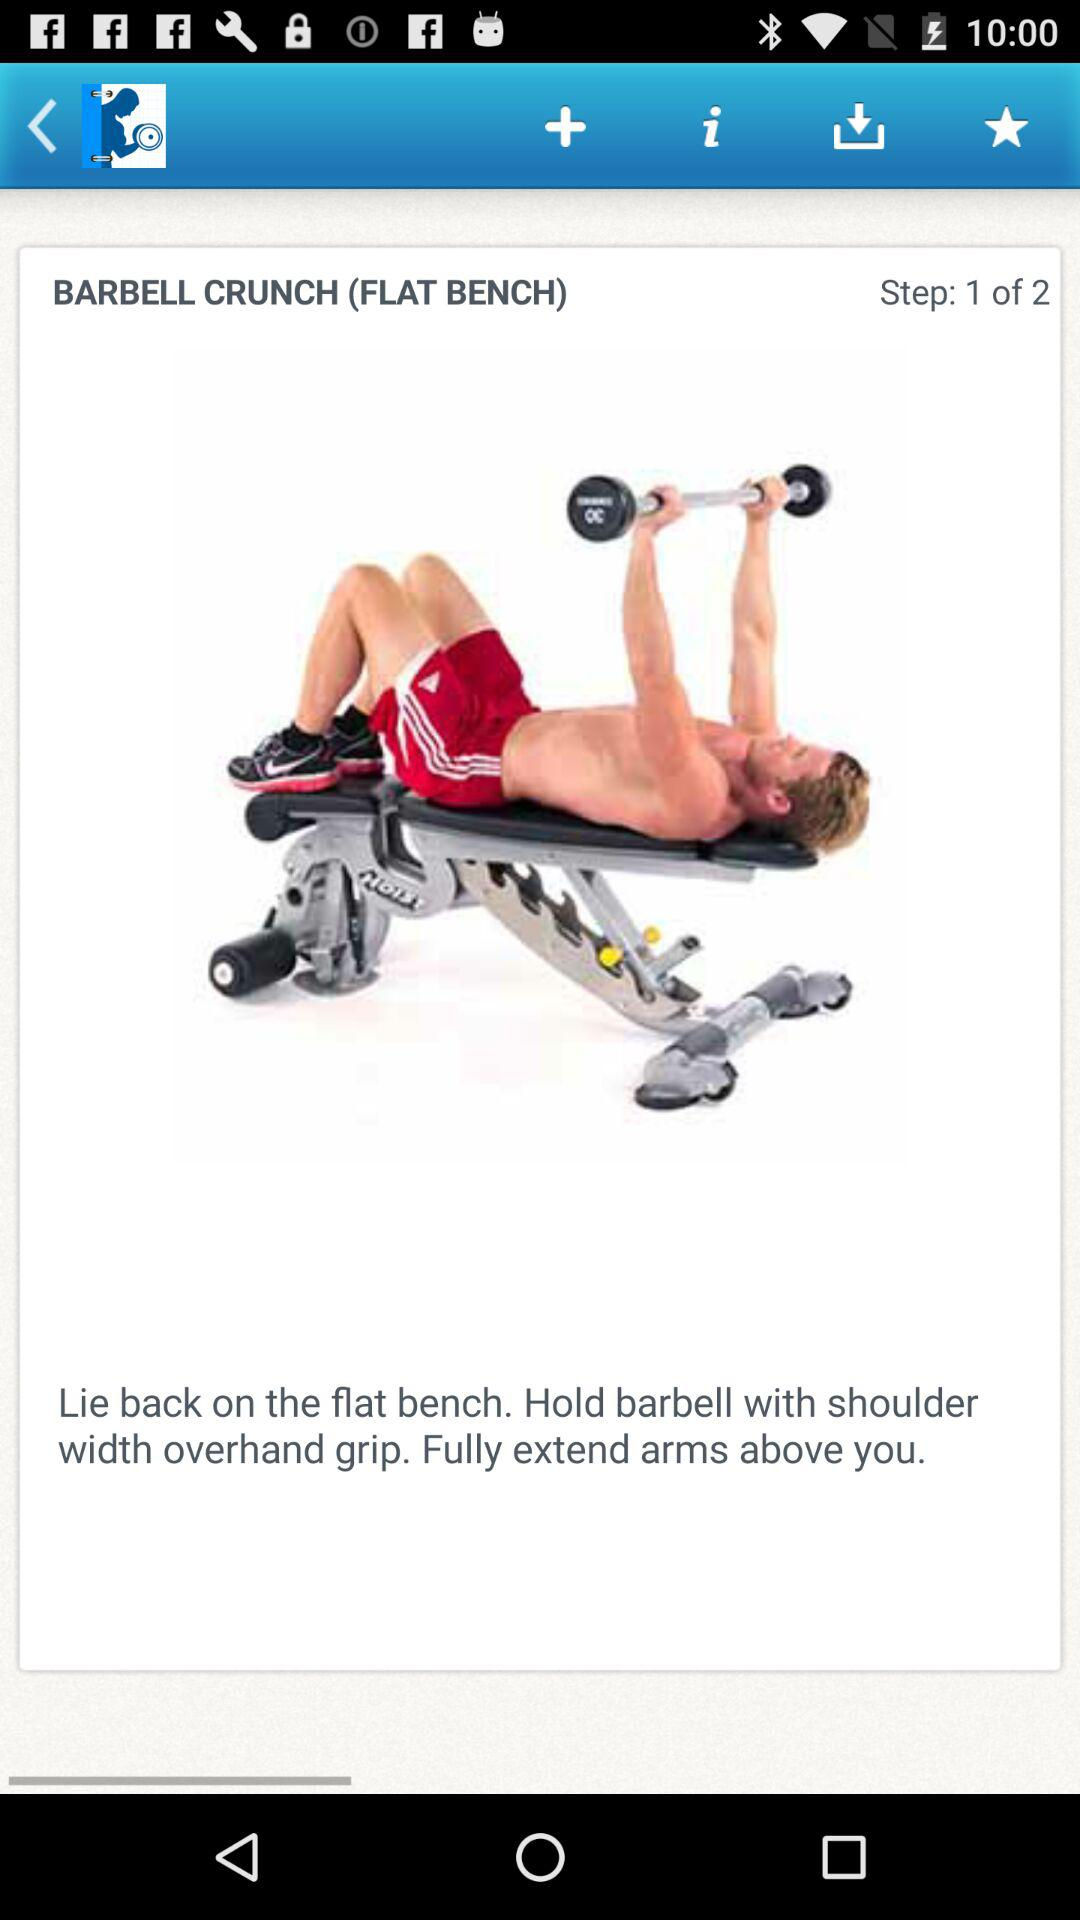What is the name of the exercise? The name of the exercise is Barbell Crunch. 